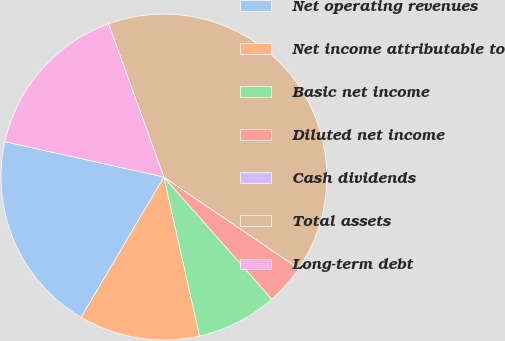Convert chart. <chart><loc_0><loc_0><loc_500><loc_500><pie_chart><fcel>Net operating revenues<fcel>Net income attributable to<fcel>Basic net income<fcel>Diluted net income<fcel>Cash dividends<fcel>Total assets<fcel>Long-term debt<nl><fcel>20.0%<fcel>12.0%<fcel>8.0%<fcel>4.0%<fcel>0.0%<fcel>40.0%<fcel>16.0%<nl></chart> 